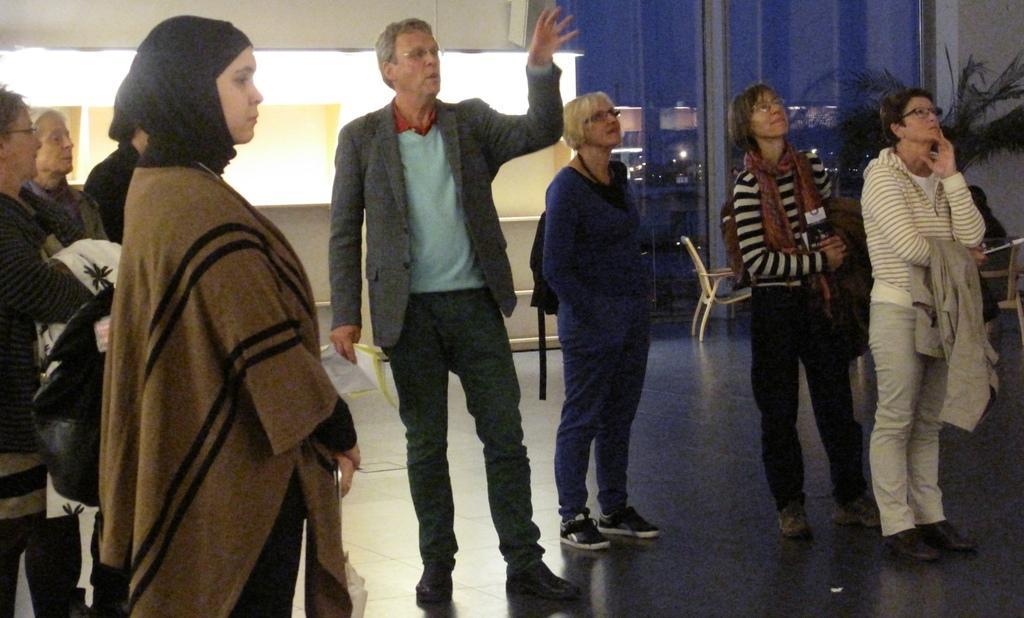In one or two sentences, can you explain what this image depicts? This image consists of many persons. In the front, the man wearing a suit is holding a paper. At the bottom, there is a floor. In the background, we can see a wall. In the middle, there is a chair. On the right, it looks like a plant. 